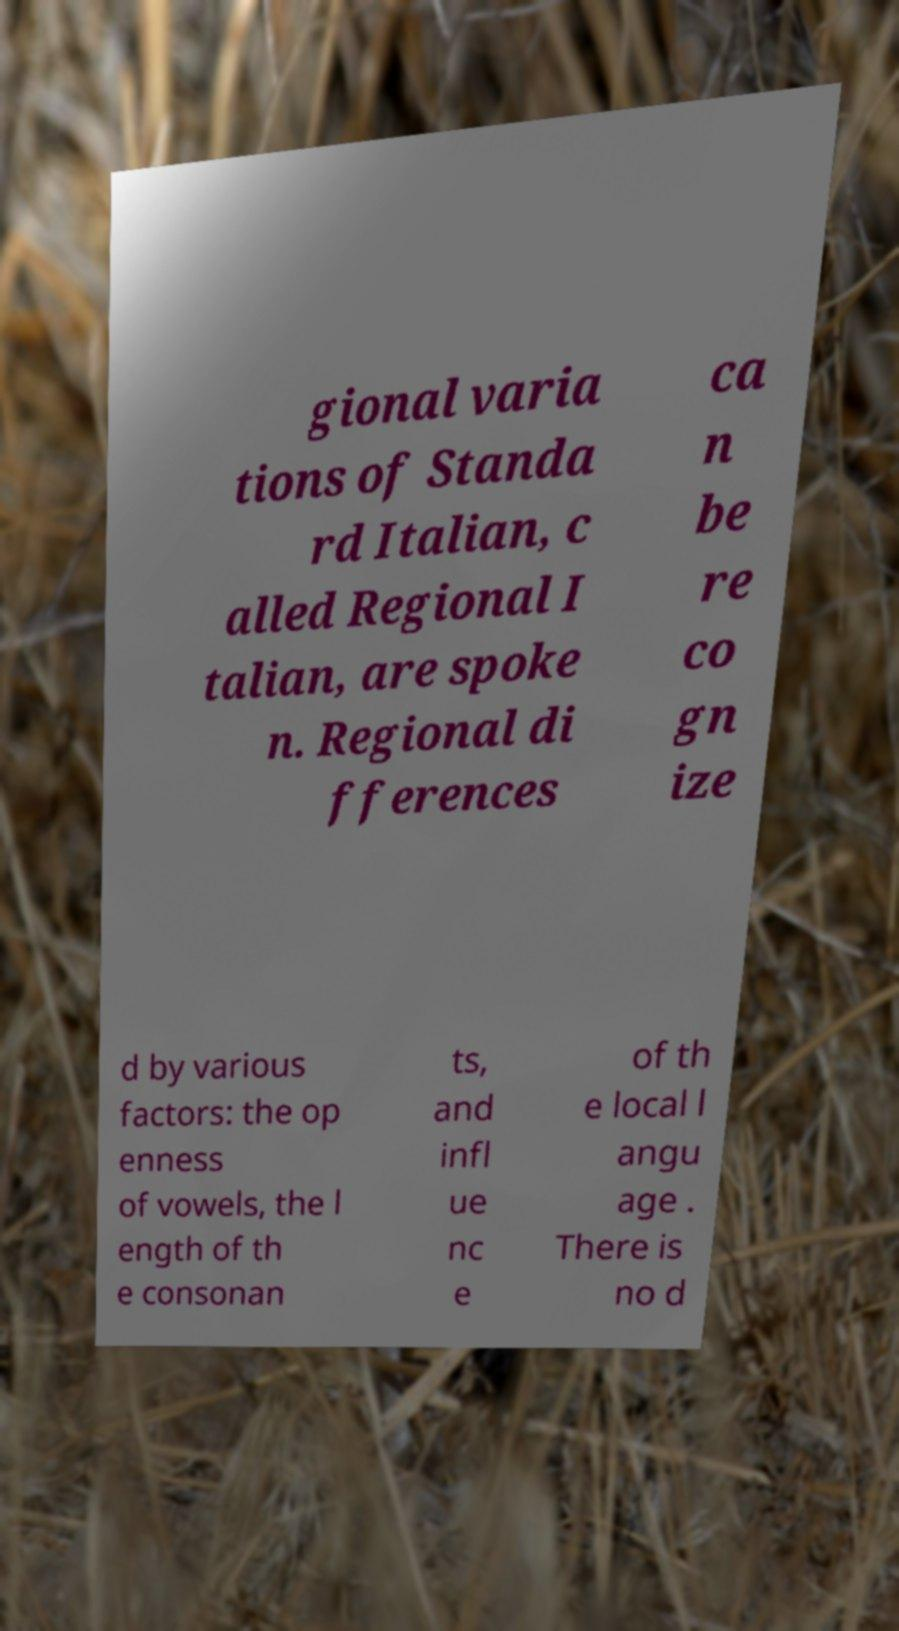Could you extract and type out the text from this image? gional varia tions of Standa rd Italian, c alled Regional I talian, are spoke n. Regional di fferences ca n be re co gn ize d by various factors: the op enness of vowels, the l ength of th e consonan ts, and infl ue nc e of th e local l angu age . There is no d 